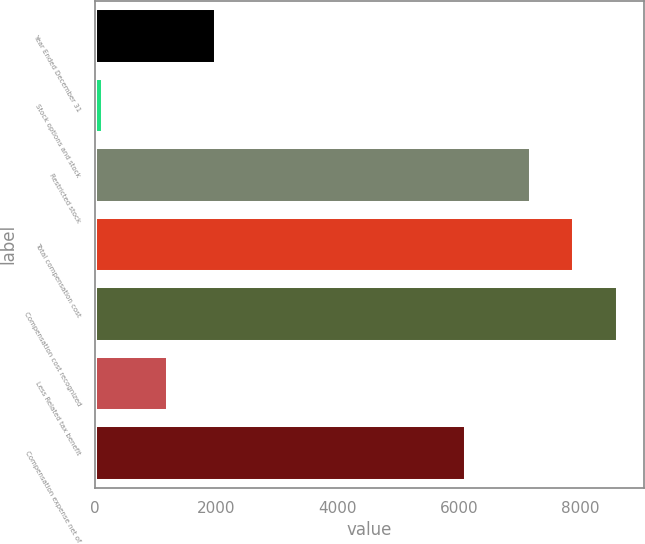<chart> <loc_0><loc_0><loc_500><loc_500><bar_chart><fcel>Year Ended December 31<fcel>Stock options and stock<fcel>Restricted stock<fcel>Total compensation cost<fcel>Compensation cost recognized<fcel>Less Related tax benefit<fcel>Compensation expense net of<nl><fcel>2005<fcel>139<fcel>7184<fcel>7902.4<fcel>8620.8<fcel>1204<fcel>6119<nl></chart> 